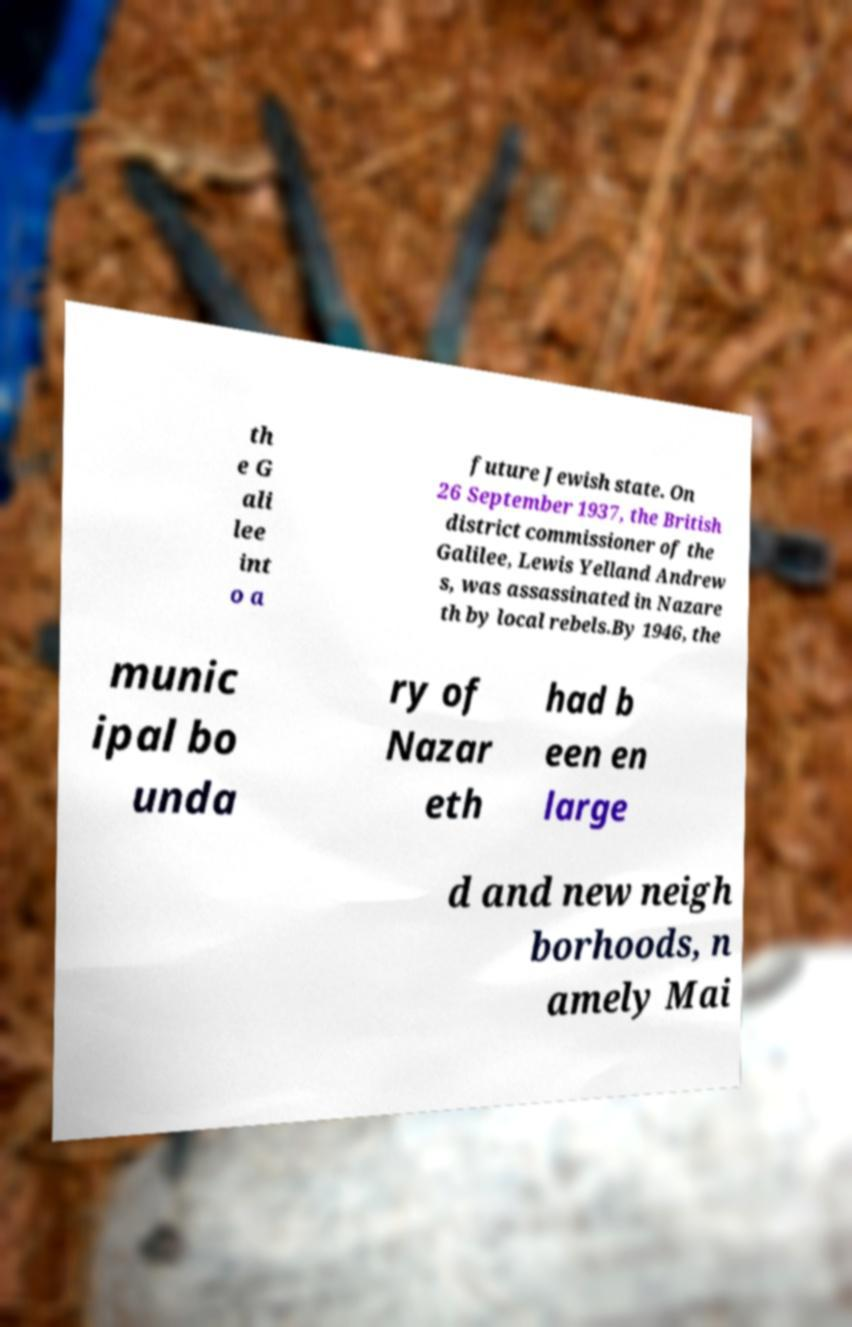There's text embedded in this image that I need extracted. Can you transcribe it verbatim? th e G ali lee int o a future Jewish state. On 26 September 1937, the British district commissioner of the Galilee, Lewis Yelland Andrew s, was assassinated in Nazare th by local rebels.By 1946, the munic ipal bo unda ry of Nazar eth had b een en large d and new neigh borhoods, n amely Mai 